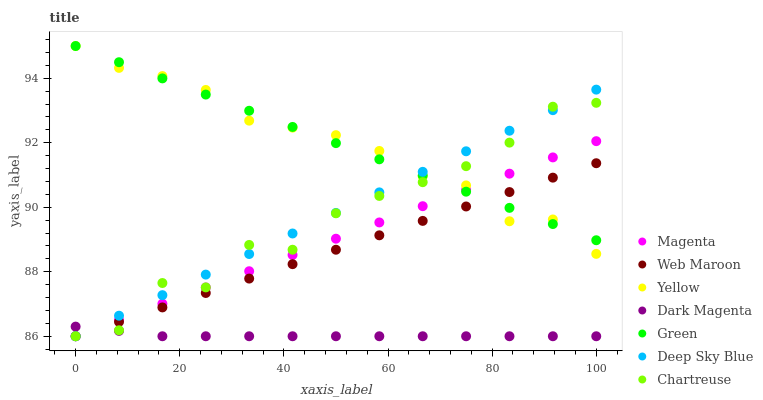Does Dark Magenta have the minimum area under the curve?
Answer yes or no. Yes. Does Green have the maximum area under the curve?
Answer yes or no. Yes. Does Web Maroon have the minimum area under the curve?
Answer yes or no. No. Does Web Maroon have the maximum area under the curve?
Answer yes or no. No. Is Web Maroon the smoothest?
Answer yes or no. Yes. Is Chartreuse the roughest?
Answer yes or no. Yes. Is Yellow the smoothest?
Answer yes or no. No. Is Yellow the roughest?
Answer yes or no. No. Does Dark Magenta have the lowest value?
Answer yes or no. Yes. Does Yellow have the lowest value?
Answer yes or no. No. Does Green have the highest value?
Answer yes or no. Yes. Does Web Maroon have the highest value?
Answer yes or no. No. Is Dark Magenta less than Yellow?
Answer yes or no. Yes. Is Green greater than Dark Magenta?
Answer yes or no. Yes. Does Green intersect Yellow?
Answer yes or no. Yes. Is Green less than Yellow?
Answer yes or no. No. Is Green greater than Yellow?
Answer yes or no. No. Does Dark Magenta intersect Yellow?
Answer yes or no. No. 